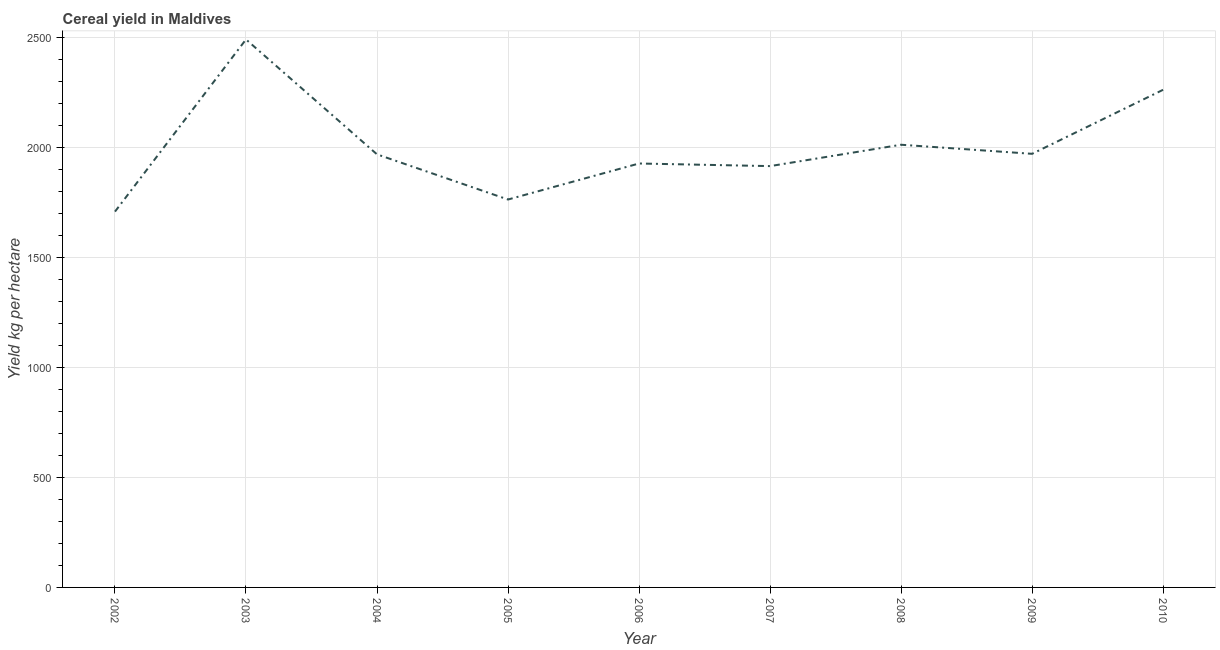What is the cereal yield in 2010?
Give a very brief answer. 2263.89. Across all years, what is the maximum cereal yield?
Keep it short and to the point. 2492.96. Across all years, what is the minimum cereal yield?
Offer a very short reply. 1709.68. In which year was the cereal yield maximum?
Keep it short and to the point. 2003. What is the sum of the cereal yield?
Your answer should be very brief. 1.80e+04. What is the difference between the cereal yield in 2002 and 2004?
Your response must be concise. -260.47. What is the average cereal yield per year?
Your answer should be compact. 2003.68. What is the median cereal yield?
Offer a very short reply. 1970.15. In how many years, is the cereal yield greater than 1100 kg per hectare?
Offer a terse response. 9. What is the ratio of the cereal yield in 2009 to that in 2010?
Your answer should be very brief. 0.87. What is the difference between the highest and the second highest cereal yield?
Make the answer very short. 229.07. Is the sum of the cereal yield in 2007 and 2009 greater than the maximum cereal yield across all years?
Offer a very short reply. Yes. What is the difference between the highest and the lowest cereal yield?
Make the answer very short. 783.28. What is the title of the graph?
Your response must be concise. Cereal yield in Maldives. What is the label or title of the Y-axis?
Make the answer very short. Yield kg per hectare. What is the Yield kg per hectare of 2002?
Offer a very short reply. 1709.68. What is the Yield kg per hectare of 2003?
Provide a short and direct response. 2492.96. What is the Yield kg per hectare in 2004?
Provide a short and direct response. 1970.15. What is the Yield kg per hectare of 2005?
Offer a very short reply. 1764.71. What is the Yield kg per hectare in 2006?
Offer a very short reply. 1928.57. What is the Yield kg per hectare of 2007?
Provide a succinct answer. 1916.67. What is the Yield kg per hectare in 2008?
Your answer should be compact. 2013.89. What is the Yield kg per hectare of 2009?
Keep it short and to the point. 1972.6. What is the Yield kg per hectare in 2010?
Your answer should be compact. 2263.89. What is the difference between the Yield kg per hectare in 2002 and 2003?
Make the answer very short. -783.28. What is the difference between the Yield kg per hectare in 2002 and 2004?
Provide a succinct answer. -260.47. What is the difference between the Yield kg per hectare in 2002 and 2005?
Ensure brevity in your answer.  -55.03. What is the difference between the Yield kg per hectare in 2002 and 2006?
Offer a very short reply. -218.89. What is the difference between the Yield kg per hectare in 2002 and 2007?
Your answer should be very brief. -206.99. What is the difference between the Yield kg per hectare in 2002 and 2008?
Your answer should be compact. -304.21. What is the difference between the Yield kg per hectare in 2002 and 2009?
Provide a short and direct response. -262.93. What is the difference between the Yield kg per hectare in 2002 and 2010?
Keep it short and to the point. -554.21. What is the difference between the Yield kg per hectare in 2003 and 2004?
Your answer should be very brief. 522.81. What is the difference between the Yield kg per hectare in 2003 and 2005?
Your response must be concise. 728.25. What is the difference between the Yield kg per hectare in 2003 and 2006?
Offer a terse response. 564.39. What is the difference between the Yield kg per hectare in 2003 and 2007?
Keep it short and to the point. 576.29. What is the difference between the Yield kg per hectare in 2003 and 2008?
Make the answer very short. 479.07. What is the difference between the Yield kg per hectare in 2003 and 2009?
Ensure brevity in your answer.  520.36. What is the difference between the Yield kg per hectare in 2003 and 2010?
Provide a succinct answer. 229.07. What is the difference between the Yield kg per hectare in 2004 and 2005?
Provide a short and direct response. 205.44. What is the difference between the Yield kg per hectare in 2004 and 2006?
Your answer should be very brief. 41.58. What is the difference between the Yield kg per hectare in 2004 and 2007?
Offer a very short reply. 53.48. What is the difference between the Yield kg per hectare in 2004 and 2008?
Offer a terse response. -43.74. What is the difference between the Yield kg per hectare in 2004 and 2009?
Your response must be concise. -2.45. What is the difference between the Yield kg per hectare in 2004 and 2010?
Keep it short and to the point. -293.74. What is the difference between the Yield kg per hectare in 2005 and 2006?
Offer a very short reply. -163.87. What is the difference between the Yield kg per hectare in 2005 and 2007?
Give a very brief answer. -151.96. What is the difference between the Yield kg per hectare in 2005 and 2008?
Keep it short and to the point. -249.18. What is the difference between the Yield kg per hectare in 2005 and 2009?
Offer a terse response. -207.9. What is the difference between the Yield kg per hectare in 2005 and 2010?
Provide a short and direct response. -499.18. What is the difference between the Yield kg per hectare in 2006 and 2007?
Make the answer very short. 11.9. What is the difference between the Yield kg per hectare in 2006 and 2008?
Keep it short and to the point. -85.32. What is the difference between the Yield kg per hectare in 2006 and 2009?
Ensure brevity in your answer.  -44.03. What is the difference between the Yield kg per hectare in 2006 and 2010?
Offer a terse response. -335.32. What is the difference between the Yield kg per hectare in 2007 and 2008?
Your answer should be compact. -97.22. What is the difference between the Yield kg per hectare in 2007 and 2009?
Your answer should be very brief. -55.94. What is the difference between the Yield kg per hectare in 2007 and 2010?
Keep it short and to the point. -347.22. What is the difference between the Yield kg per hectare in 2008 and 2009?
Your answer should be very brief. 41.29. What is the difference between the Yield kg per hectare in 2008 and 2010?
Provide a succinct answer. -250. What is the difference between the Yield kg per hectare in 2009 and 2010?
Offer a terse response. -291.29. What is the ratio of the Yield kg per hectare in 2002 to that in 2003?
Provide a succinct answer. 0.69. What is the ratio of the Yield kg per hectare in 2002 to that in 2004?
Provide a short and direct response. 0.87. What is the ratio of the Yield kg per hectare in 2002 to that in 2006?
Your response must be concise. 0.89. What is the ratio of the Yield kg per hectare in 2002 to that in 2007?
Your response must be concise. 0.89. What is the ratio of the Yield kg per hectare in 2002 to that in 2008?
Your answer should be very brief. 0.85. What is the ratio of the Yield kg per hectare in 2002 to that in 2009?
Offer a terse response. 0.87. What is the ratio of the Yield kg per hectare in 2002 to that in 2010?
Make the answer very short. 0.76. What is the ratio of the Yield kg per hectare in 2003 to that in 2004?
Make the answer very short. 1.26. What is the ratio of the Yield kg per hectare in 2003 to that in 2005?
Make the answer very short. 1.41. What is the ratio of the Yield kg per hectare in 2003 to that in 2006?
Provide a succinct answer. 1.29. What is the ratio of the Yield kg per hectare in 2003 to that in 2007?
Give a very brief answer. 1.3. What is the ratio of the Yield kg per hectare in 2003 to that in 2008?
Make the answer very short. 1.24. What is the ratio of the Yield kg per hectare in 2003 to that in 2009?
Your response must be concise. 1.26. What is the ratio of the Yield kg per hectare in 2003 to that in 2010?
Your answer should be very brief. 1.1. What is the ratio of the Yield kg per hectare in 2004 to that in 2005?
Provide a short and direct response. 1.12. What is the ratio of the Yield kg per hectare in 2004 to that in 2007?
Provide a short and direct response. 1.03. What is the ratio of the Yield kg per hectare in 2004 to that in 2010?
Make the answer very short. 0.87. What is the ratio of the Yield kg per hectare in 2005 to that in 2006?
Provide a short and direct response. 0.92. What is the ratio of the Yield kg per hectare in 2005 to that in 2007?
Provide a short and direct response. 0.92. What is the ratio of the Yield kg per hectare in 2005 to that in 2008?
Provide a succinct answer. 0.88. What is the ratio of the Yield kg per hectare in 2005 to that in 2009?
Offer a very short reply. 0.9. What is the ratio of the Yield kg per hectare in 2005 to that in 2010?
Provide a succinct answer. 0.78. What is the ratio of the Yield kg per hectare in 2006 to that in 2007?
Your answer should be very brief. 1.01. What is the ratio of the Yield kg per hectare in 2006 to that in 2008?
Make the answer very short. 0.96. What is the ratio of the Yield kg per hectare in 2006 to that in 2010?
Your answer should be very brief. 0.85. What is the ratio of the Yield kg per hectare in 2007 to that in 2009?
Your response must be concise. 0.97. What is the ratio of the Yield kg per hectare in 2007 to that in 2010?
Make the answer very short. 0.85. What is the ratio of the Yield kg per hectare in 2008 to that in 2009?
Offer a terse response. 1.02. What is the ratio of the Yield kg per hectare in 2008 to that in 2010?
Keep it short and to the point. 0.89. What is the ratio of the Yield kg per hectare in 2009 to that in 2010?
Ensure brevity in your answer.  0.87. 